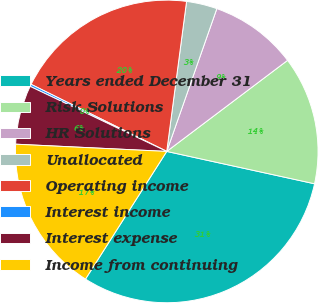Convert chart to OTSL. <chart><loc_0><loc_0><loc_500><loc_500><pie_chart><fcel>Years ended December 31<fcel>Risk Solutions<fcel>HR Solutions<fcel>Unallocated<fcel>Operating income<fcel>Interest income<fcel>Interest expense<fcel>Income from continuing<nl><fcel>30.59%<fcel>13.71%<fcel>9.35%<fcel>3.28%<fcel>19.78%<fcel>0.24%<fcel>6.31%<fcel>16.74%<nl></chart> 